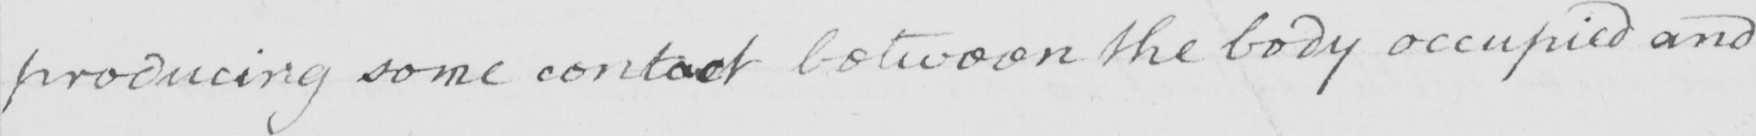Can you read and transcribe this handwriting? producing some contact between the body occupied and 